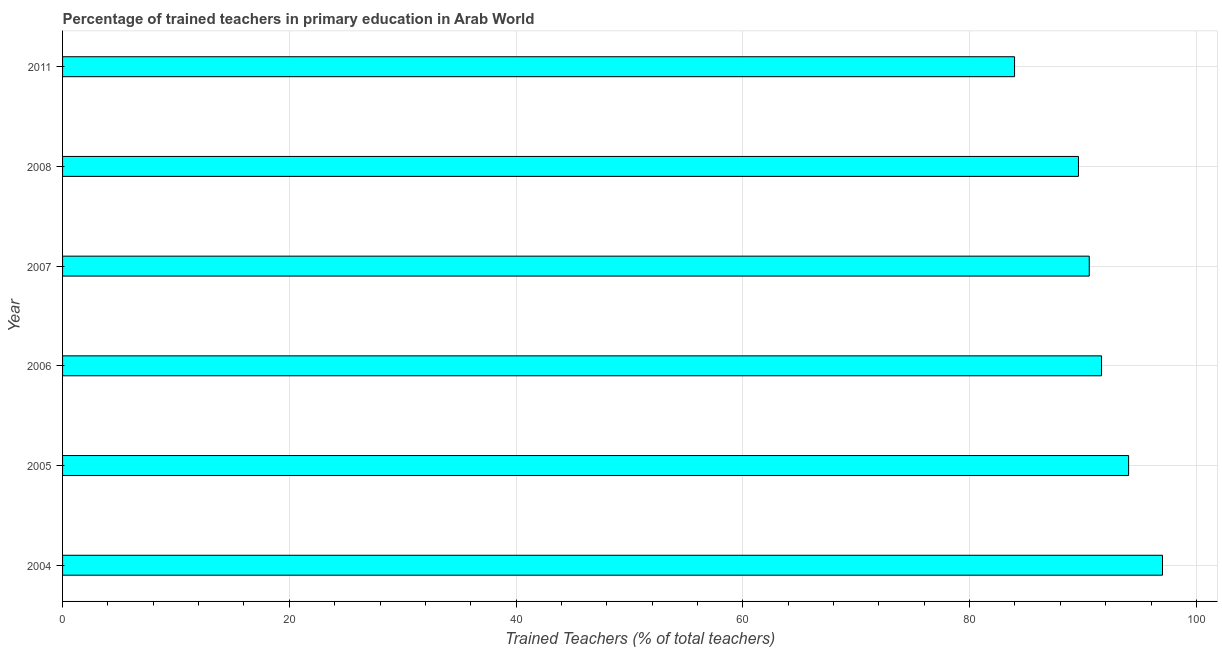Does the graph contain any zero values?
Ensure brevity in your answer.  No. Does the graph contain grids?
Offer a terse response. Yes. What is the title of the graph?
Offer a very short reply. Percentage of trained teachers in primary education in Arab World. What is the label or title of the X-axis?
Offer a terse response. Trained Teachers (% of total teachers). What is the percentage of trained teachers in 2006?
Give a very brief answer. 91.63. Across all years, what is the maximum percentage of trained teachers?
Your response must be concise. 97.01. Across all years, what is the minimum percentage of trained teachers?
Provide a succinct answer. 83.96. What is the sum of the percentage of trained teachers?
Provide a succinct answer. 546.78. What is the difference between the percentage of trained teachers in 2004 and 2008?
Provide a succinct answer. 7.41. What is the average percentage of trained teachers per year?
Your answer should be compact. 91.13. What is the median percentage of trained teachers?
Provide a succinct answer. 91.09. In how many years, is the percentage of trained teachers greater than 72 %?
Your response must be concise. 6. What is the ratio of the percentage of trained teachers in 2004 to that in 2007?
Offer a very short reply. 1.07. Is the percentage of trained teachers in 2004 less than that in 2011?
Offer a very short reply. No. Is the difference between the percentage of trained teachers in 2006 and 2008 greater than the difference between any two years?
Ensure brevity in your answer.  No. What is the difference between the highest and the second highest percentage of trained teachers?
Provide a short and direct response. 2.99. What is the difference between the highest and the lowest percentage of trained teachers?
Your answer should be compact. 13.05. How many bars are there?
Offer a very short reply. 6. How many years are there in the graph?
Offer a very short reply. 6. What is the difference between two consecutive major ticks on the X-axis?
Provide a short and direct response. 20. What is the Trained Teachers (% of total teachers) in 2004?
Your answer should be very brief. 97.01. What is the Trained Teachers (% of total teachers) of 2005?
Your answer should be very brief. 94.02. What is the Trained Teachers (% of total teachers) of 2006?
Offer a very short reply. 91.63. What is the Trained Teachers (% of total teachers) of 2007?
Give a very brief answer. 90.55. What is the Trained Teachers (% of total teachers) in 2008?
Provide a short and direct response. 89.6. What is the Trained Teachers (% of total teachers) in 2011?
Give a very brief answer. 83.96. What is the difference between the Trained Teachers (% of total teachers) in 2004 and 2005?
Provide a succinct answer. 2.99. What is the difference between the Trained Teachers (% of total teachers) in 2004 and 2006?
Ensure brevity in your answer.  5.38. What is the difference between the Trained Teachers (% of total teachers) in 2004 and 2007?
Keep it short and to the point. 6.46. What is the difference between the Trained Teachers (% of total teachers) in 2004 and 2008?
Keep it short and to the point. 7.41. What is the difference between the Trained Teachers (% of total teachers) in 2004 and 2011?
Offer a very short reply. 13.05. What is the difference between the Trained Teachers (% of total teachers) in 2005 and 2006?
Provide a succinct answer. 2.39. What is the difference between the Trained Teachers (% of total teachers) in 2005 and 2007?
Your answer should be compact. 3.47. What is the difference between the Trained Teachers (% of total teachers) in 2005 and 2008?
Ensure brevity in your answer.  4.42. What is the difference between the Trained Teachers (% of total teachers) in 2005 and 2011?
Your answer should be very brief. 10.06. What is the difference between the Trained Teachers (% of total teachers) in 2006 and 2007?
Your answer should be compact. 1.08. What is the difference between the Trained Teachers (% of total teachers) in 2006 and 2008?
Ensure brevity in your answer.  2.04. What is the difference between the Trained Teachers (% of total teachers) in 2006 and 2011?
Your response must be concise. 7.67. What is the difference between the Trained Teachers (% of total teachers) in 2007 and 2008?
Offer a terse response. 0.95. What is the difference between the Trained Teachers (% of total teachers) in 2007 and 2011?
Keep it short and to the point. 6.59. What is the difference between the Trained Teachers (% of total teachers) in 2008 and 2011?
Ensure brevity in your answer.  5.64. What is the ratio of the Trained Teachers (% of total teachers) in 2004 to that in 2005?
Ensure brevity in your answer.  1.03. What is the ratio of the Trained Teachers (% of total teachers) in 2004 to that in 2006?
Your answer should be very brief. 1.06. What is the ratio of the Trained Teachers (% of total teachers) in 2004 to that in 2007?
Keep it short and to the point. 1.07. What is the ratio of the Trained Teachers (% of total teachers) in 2004 to that in 2008?
Keep it short and to the point. 1.08. What is the ratio of the Trained Teachers (% of total teachers) in 2004 to that in 2011?
Offer a very short reply. 1.16. What is the ratio of the Trained Teachers (% of total teachers) in 2005 to that in 2007?
Provide a succinct answer. 1.04. What is the ratio of the Trained Teachers (% of total teachers) in 2005 to that in 2008?
Offer a terse response. 1.05. What is the ratio of the Trained Teachers (% of total teachers) in 2005 to that in 2011?
Provide a short and direct response. 1.12. What is the ratio of the Trained Teachers (% of total teachers) in 2006 to that in 2007?
Your answer should be compact. 1.01. What is the ratio of the Trained Teachers (% of total teachers) in 2006 to that in 2011?
Offer a very short reply. 1.09. What is the ratio of the Trained Teachers (% of total teachers) in 2007 to that in 2011?
Ensure brevity in your answer.  1.08. What is the ratio of the Trained Teachers (% of total teachers) in 2008 to that in 2011?
Your answer should be compact. 1.07. 